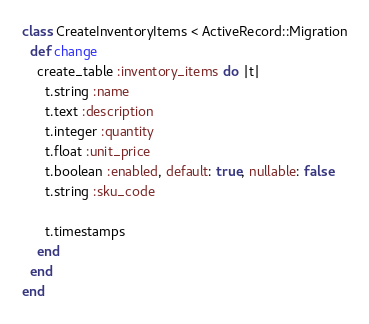<code> <loc_0><loc_0><loc_500><loc_500><_Ruby_>class CreateInventoryItems < ActiveRecord::Migration
  def change
    create_table :inventory_items do |t|
      t.string :name
      t.text :description
      t.integer :quantity
      t.float :unit_price
      t.boolean :enabled, default: true, nullable: false
      t.string :sku_code

      t.timestamps
    end
  end
end
</code> 